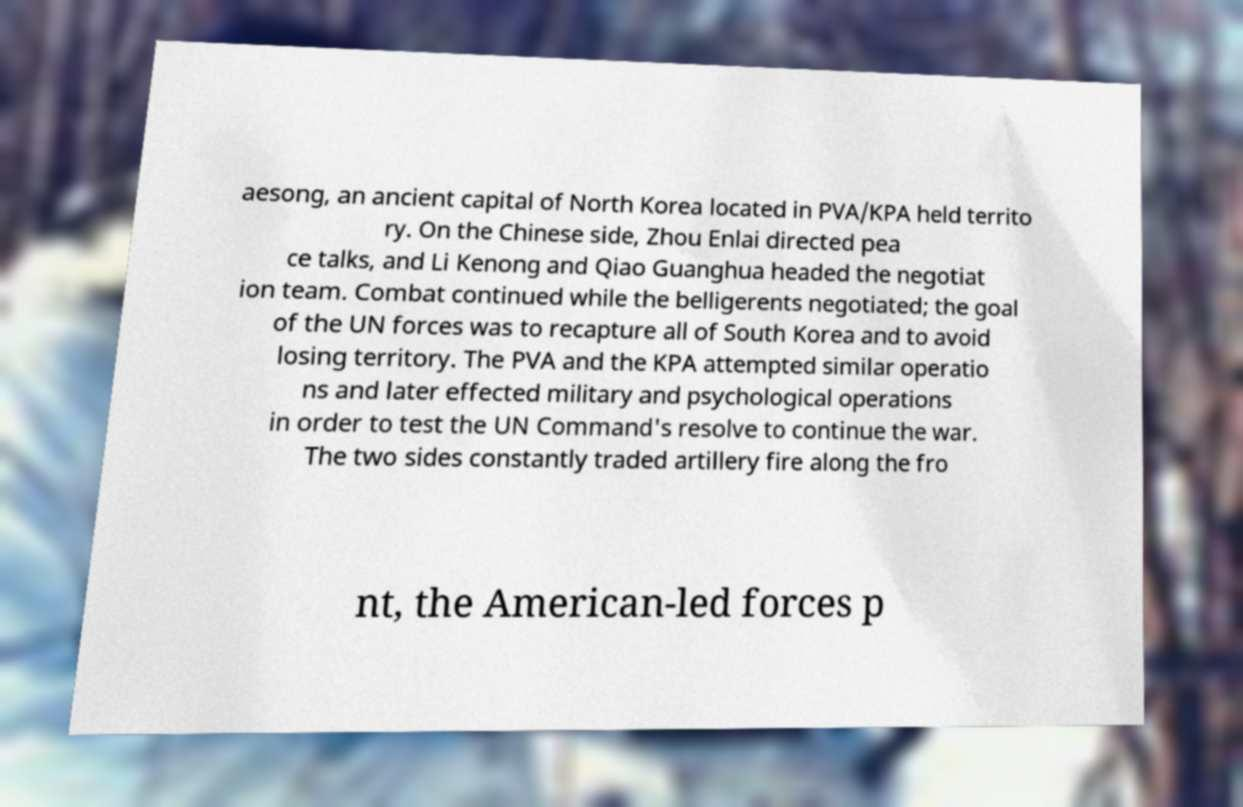Could you assist in decoding the text presented in this image and type it out clearly? aesong, an ancient capital of North Korea located in PVA/KPA held territo ry. On the Chinese side, Zhou Enlai directed pea ce talks, and Li Kenong and Qiao Guanghua headed the negotiat ion team. Combat continued while the belligerents negotiated; the goal of the UN forces was to recapture all of South Korea and to avoid losing territory. The PVA and the KPA attempted similar operatio ns and later effected military and psychological operations in order to test the UN Command's resolve to continue the war. The two sides constantly traded artillery fire along the fro nt, the American-led forces p 